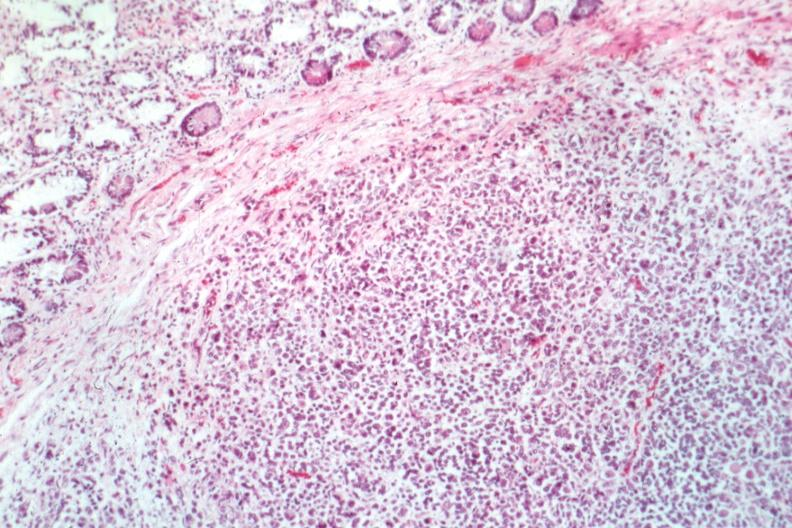what is present?
Answer the question using a single word or phrase. Small intestine 